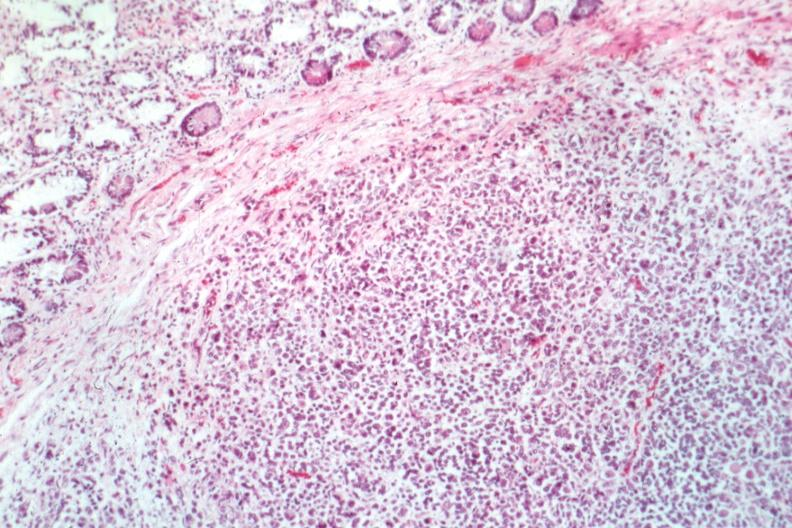what is present?
Answer the question using a single word or phrase. Small intestine 